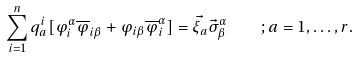<formula> <loc_0><loc_0><loc_500><loc_500>\sum _ { i = 1 } ^ { n } q _ { a } ^ { i } [ \varphi _ { i } ^ { \alpha } \overline { \varphi } _ { i \beta } + \varphi _ { i \beta } \overline { \varphi } _ { i } ^ { \alpha } ] = \vec { \xi _ { a } } \vec { \sigma } _ { \beta } ^ { \alpha } \quad ; a = 1 , \dots , r .</formula> 